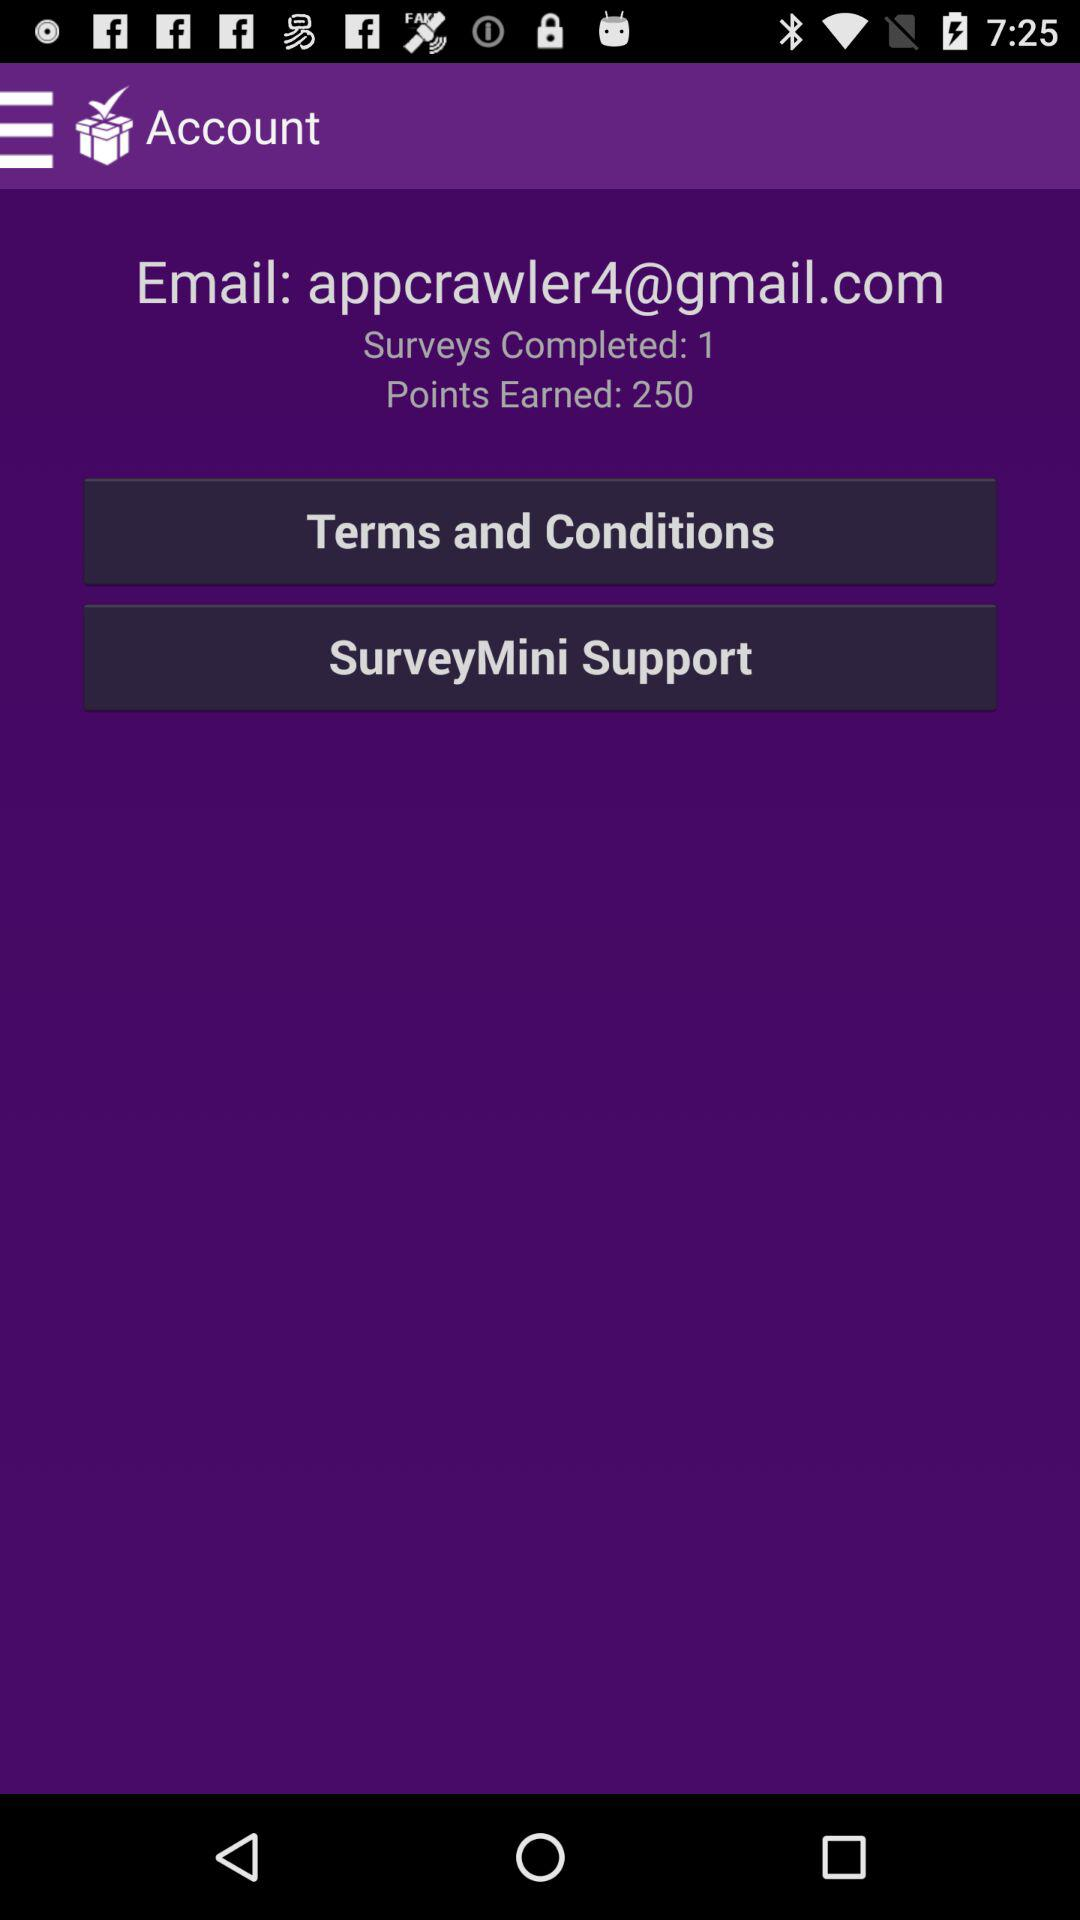What is the given email address? The given email address is appcrawler4@gmail.com. 